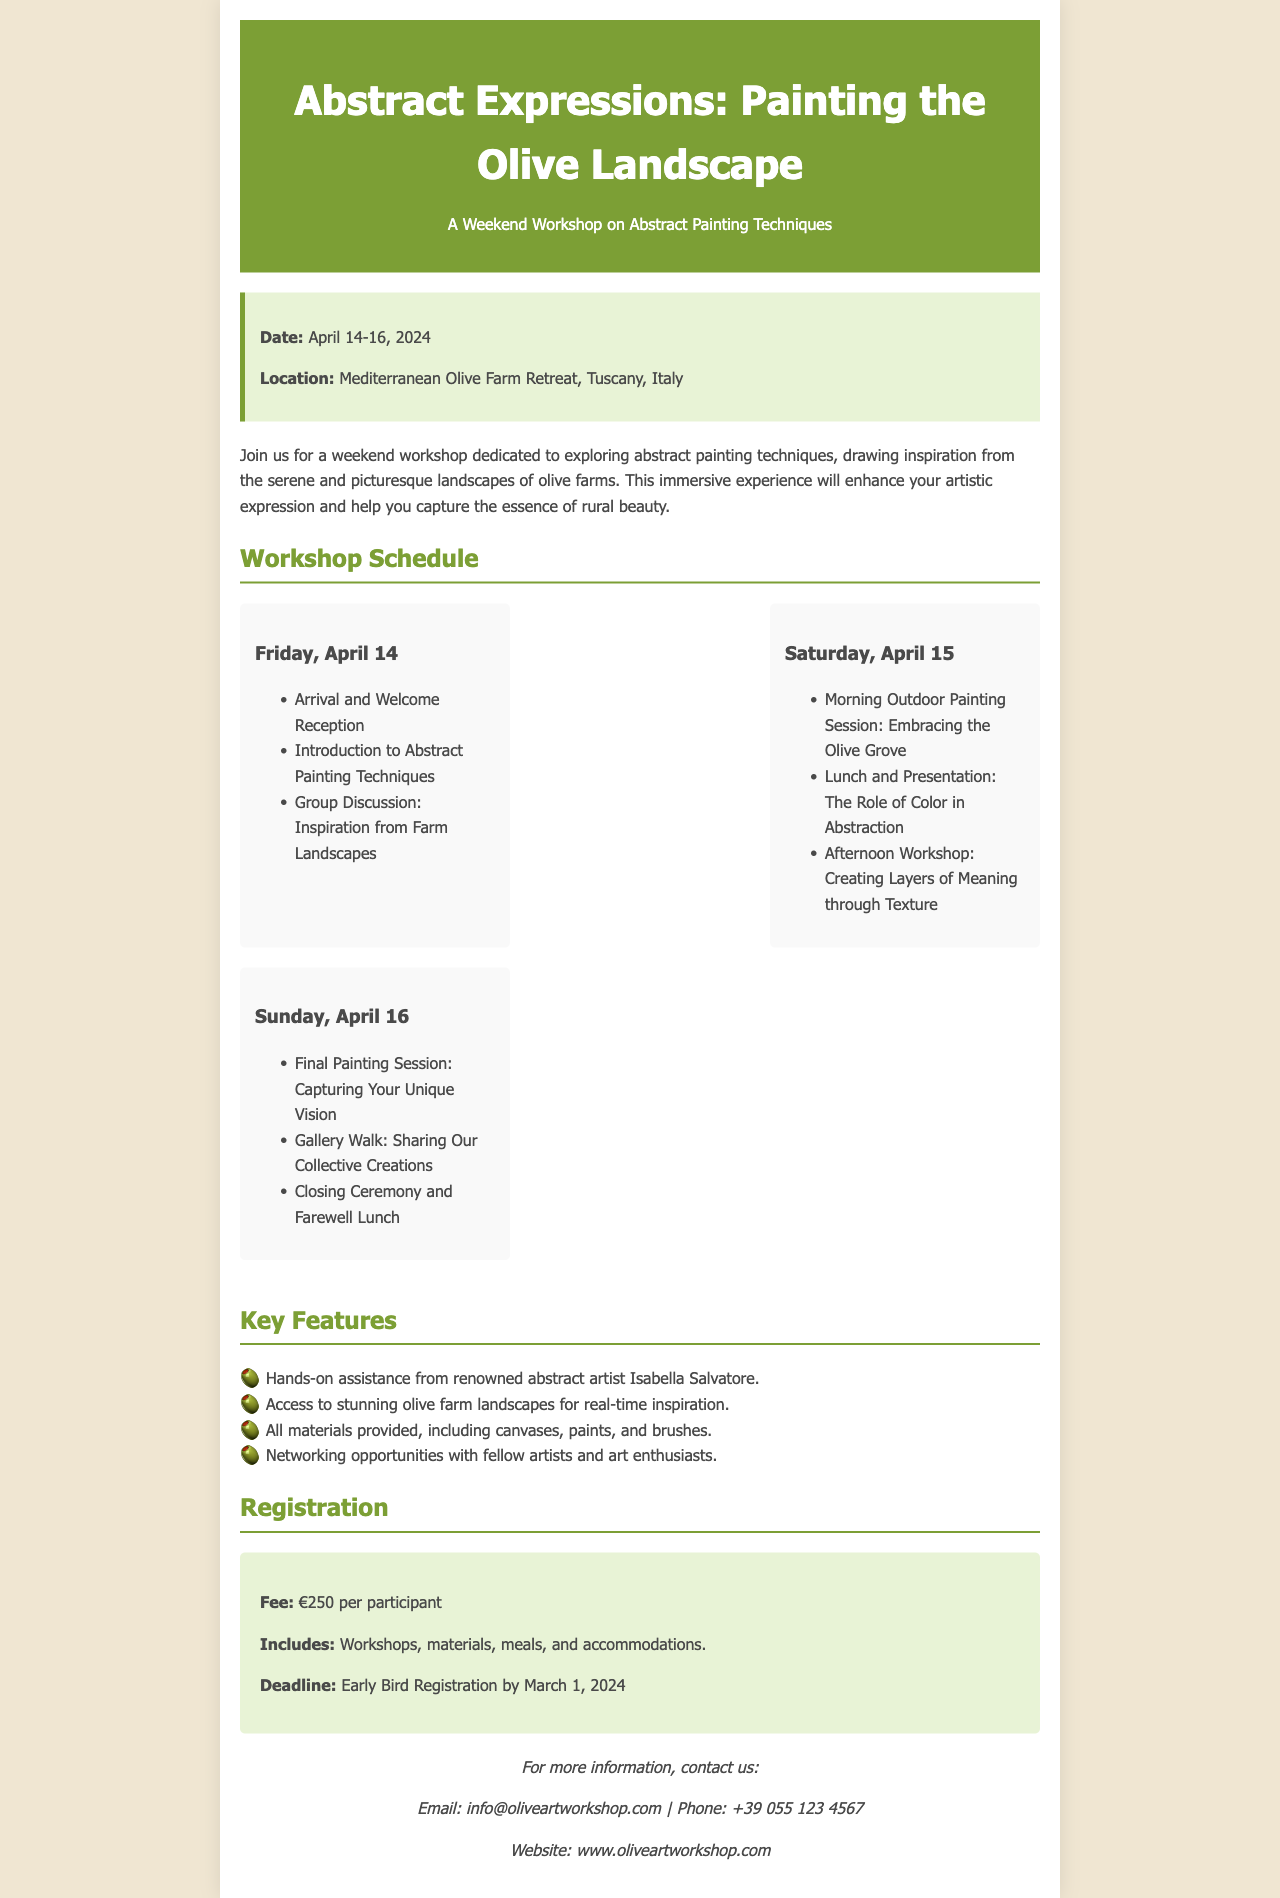What are the dates of the workshop? The dates of the workshop are specified in the document as from April 14 to April 16, 2024.
Answer: April 14-16, 2024 Where is the workshop located? The location of the workshop is mentioned as the Mediterranean Olive Farm Retreat in Tuscany, Italy.
Answer: Mediterranean Olive Farm Retreat, Tuscany, Italy Who is the renowned abstract artist mentioned in the workshop? The document identifies Isabella Salvatore as the renowned abstract artist providing assistance during the workshop.
Answer: Isabella Salvatore What is the registration fee for the workshop? The fee for the workshop is provided in the document, listed as €250 per participant.
Answer: €250 What is included in the registration fee? The document outlines that the registration fee includes workshops, materials, meals, and accommodations.
Answer: Workshops, materials, meals, and accommodations What specific artistic technique will be explored on Saturday? The workshop includes a morning outdoor painting session focused on embracing the olive grove as part of the Saturday activities.
Answer: Embracing the Olive Grove What is the deadline for early bird registration? The deadline for early bird registration is stated as March 1, 2024, according to the information in the document.
Answer: March 1, 2024 What is a featured activity of the workshop on Sunday? The final painting session, where participants capture their unique vision, is highlighted as an activity for Sunday.
Answer: Capturing Your Unique Vision How will participants share their work at the end of the workshop? A gallery walk is mentioned as the event where participants will share their collective creations.
Answer: Gallery Walk 